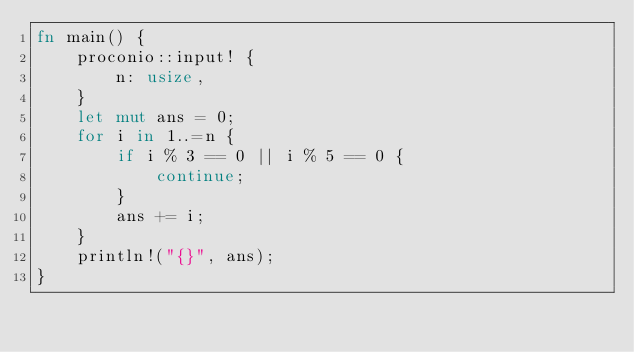<code> <loc_0><loc_0><loc_500><loc_500><_Rust_>fn main() {
    proconio::input! {
        n: usize,
    }
    let mut ans = 0;
    for i in 1..=n {
        if i % 3 == 0 || i % 5 == 0 {
            continue;
        }
        ans += i;
    }
    println!("{}", ans);
}
</code> 